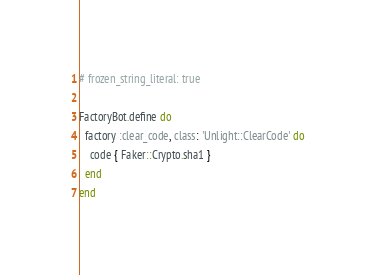<code> <loc_0><loc_0><loc_500><loc_500><_Ruby_># frozen_string_literal: true

FactoryBot.define do
  factory :clear_code, class: 'Unlight::ClearCode' do
    code { Faker::Crypto.sha1 }
  end
end
</code> 